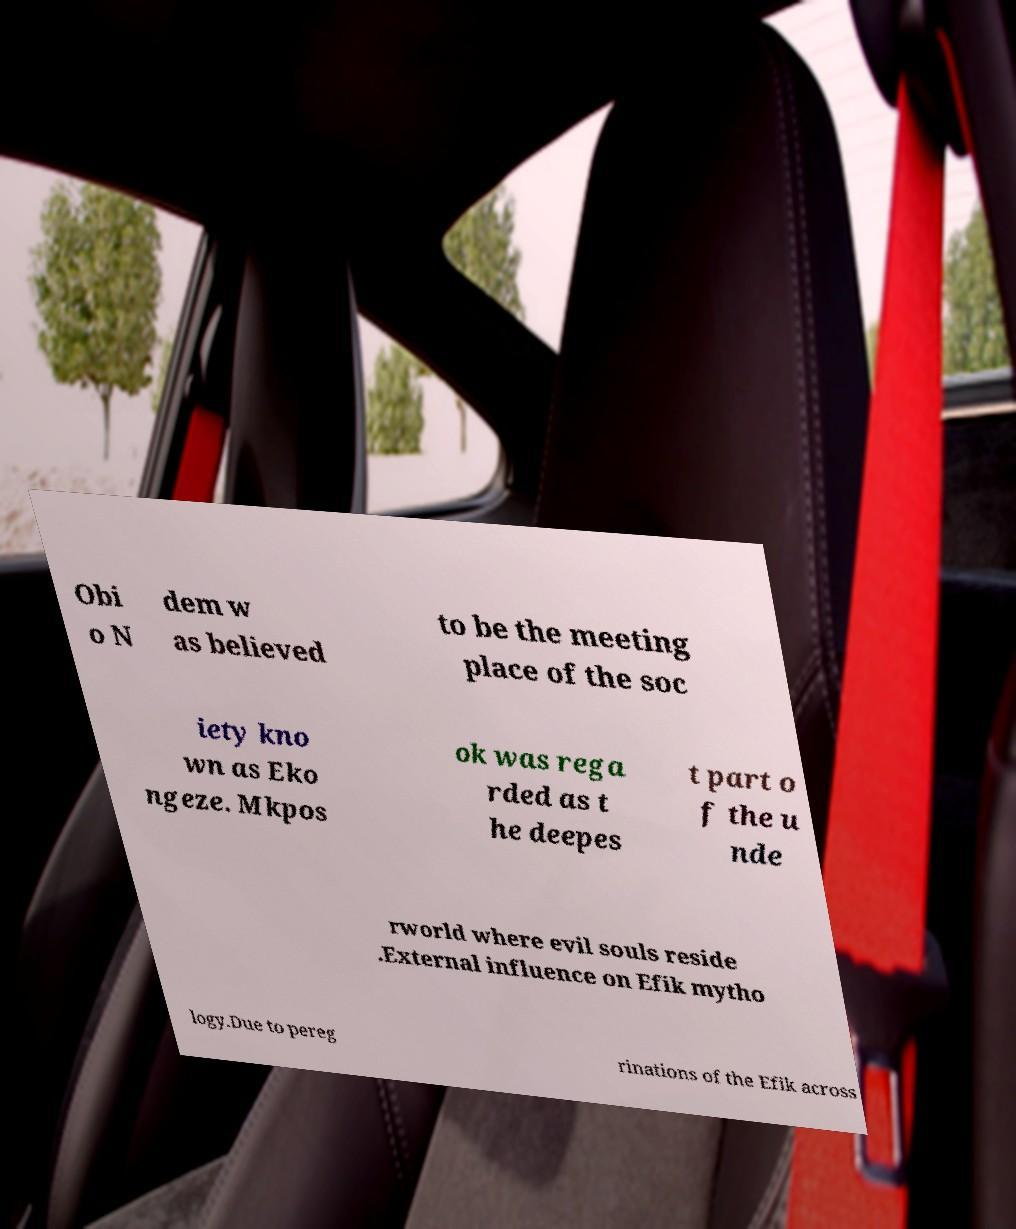Could you extract and type out the text from this image? Obi o N dem w as believed to be the meeting place of the soc iety kno wn as Eko ngeze. Mkpos ok was rega rded as t he deepes t part o f the u nde rworld where evil souls reside .External influence on Efik mytho logy.Due to pereg rinations of the Efik across 